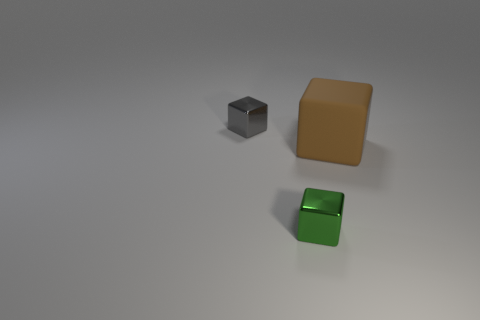Is there a block behind the small shiny block to the right of the tiny gray metal thing?
Provide a succinct answer. Yes. Do the small metallic thing right of the gray metal thing and the thing behind the big brown rubber object have the same shape?
Ensure brevity in your answer.  Yes. Is the tiny thing that is in front of the big matte object made of the same material as the block that is behind the large cube?
Give a very brief answer. Yes. The small gray block that is behind the tiny shiny object that is in front of the big brown cube is made of what material?
Your response must be concise. Metal. What shape is the tiny object that is in front of the small metal thing that is behind the small metal block in front of the brown object?
Make the answer very short. Cube. What is the material of the small gray thing that is the same shape as the brown thing?
Provide a succinct answer. Metal. How many big blue cylinders are there?
Your answer should be very brief. 0. The tiny object on the right side of the gray metallic block has what shape?
Give a very brief answer. Cube. What is the color of the tiny block that is behind the small shiny object that is right of the tiny object that is behind the green object?
Provide a succinct answer. Gray. The gray object that is made of the same material as the green cube is what shape?
Make the answer very short. Cube. 